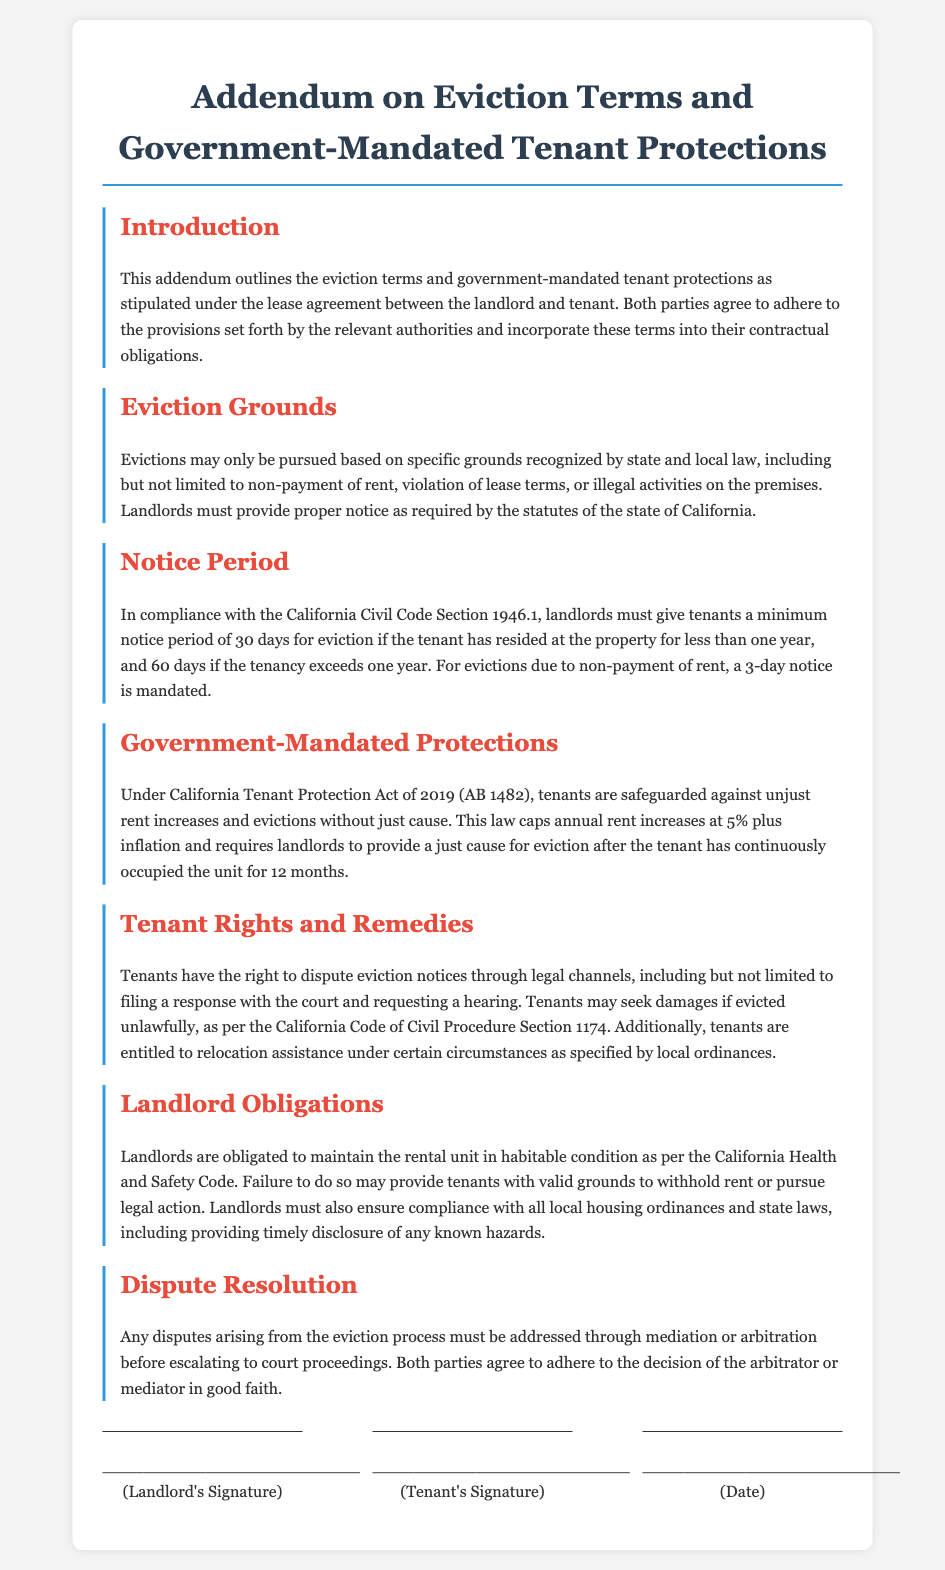What is the title of the document? The title is the main heading of the document that indicates its purpose.
Answer: Addendum on Eviction Terms and Government-Mandated Tenant Protections What is the minimum notice period for eviction if the tenant has resided for less than one year? This refers to the timeframe that landlords must adhere to when notifying tenants of an eviction based on their duration of residency.
Answer: 30 days What must landlords provide for eviction due to non-payment of rent? This specifies the requirement that landlords must fulfill to initiate an eviction for rent issues.
Answer: 3-day notice What act protects tenants against unjust rent increases? This identifies the specific legislation that safeguards tenants' rights related to rent adjustments.
Answer: California Tenant Protection Act of 2019 (AB 1482) How many days notice is required for eviction if the tenancy exceeds one year? This relates to the notice requirement based on the tenure of the tenant at the property.
Answer: 60 days What grounds are valid for eviction as per the document? This question addresses the acceptable reasons for landlords to evict tenants as outlined in the document.
Answer: Non-payment of rent, violation of lease terms, illegal activities What obligation do landlords have regarding the rental unit? This concerns the responsibilities of landlords in regard to the maintenance and condition of their rental properties.
Answer: Maintain the rental unit in habitable condition What are tenants entitled to seek if evicted unlawfully? This describes the legal recourse available to tenants when they believe an eviction is improper.
Answer: Damages What type of resolution process is suggested for disputes arising from eviction? This refers to the method proposed for resolving disagreements before escalating to the courts.
Answer: Mediation or arbitration 